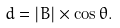<formula> <loc_0><loc_0><loc_500><loc_500>d = | { B } | \times \cos \theta .</formula> 